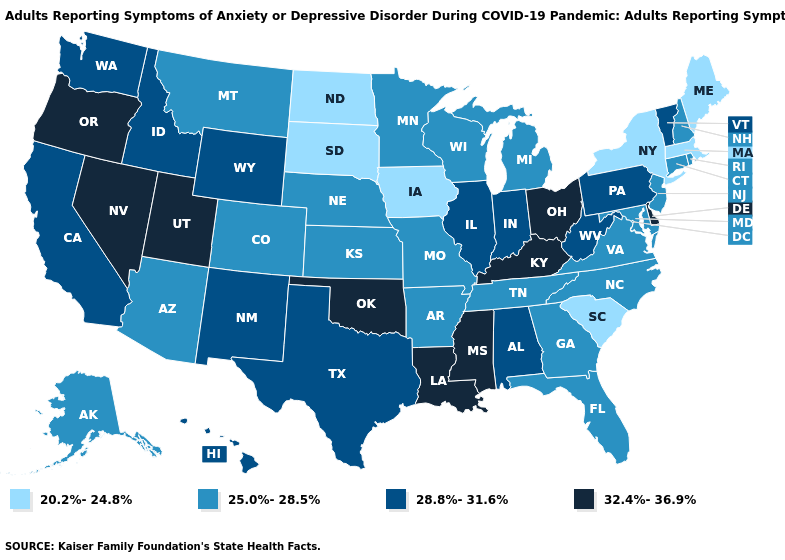Name the states that have a value in the range 20.2%-24.8%?
Answer briefly. Iowa, Maine, Massachusetts, New York, North Dakota, South Carolina, South Dakota. Name the states that have a value in the range 28.8%-31.6%?
Give a very brief answer. Alabama, California, Hawaii, Idaho, Illinois, Indiana, New Mexico, Pennsylvania, Texas, Vermont, Washington, West Virginia, Wyoming. What is the value of Arizona?
Answer briefly. 25.0%-28.5%. Does the first symbol in the legend represent the smallest category?
Give a very brief answer. Yes. What is the value of South Dakota?
Concise answer only. 20.2%-24.8%. What is the value of Virginia?
Keep it brief. 25.0%-28.5%. Name the states that have a value in the range 25.0%-28.5%?
Be succinct. Alaska, Arizona, Arkansas, Colorado, Connecticut, Florida, Georgia, Kansas, Maryland, Michigan, Minnesota, Missouri, Montana, Nebraska, New Hampshire, New Jersey, North Carolina, Rhode Island, Tennessee, Virginia, Wisconsin. Name the states that have a value in the range 32.4%-36.9%?
Concise answer only. Delaware, Kentucky, Louisiana, Mississippi, Nevada, Ohio, Oklahoma, Oregon, Utah. How many symbols are there in the legend?
Short answer required. 4. What is the highest value in states that border North Carolina?
Write a very short answer. 25.0%-28.5%. Which states have the highest value in the USA?
Write a very short answer. Delaware, Kentucky, Louisiana, Mississippi, Nevada, Ohio, Oklahoma, Oregon, Utah. Is the legend a continuous bar?
Short answer required. No. Does Louisiana have the same value as Mississippi?
Write a very short answer. Yes. What is the lowest value in the Northeast?
Concise answer only. 20.2%-24.8%. Among the states that border Kentucky , does Missouri have the highest value?
Quick response, please. No. 